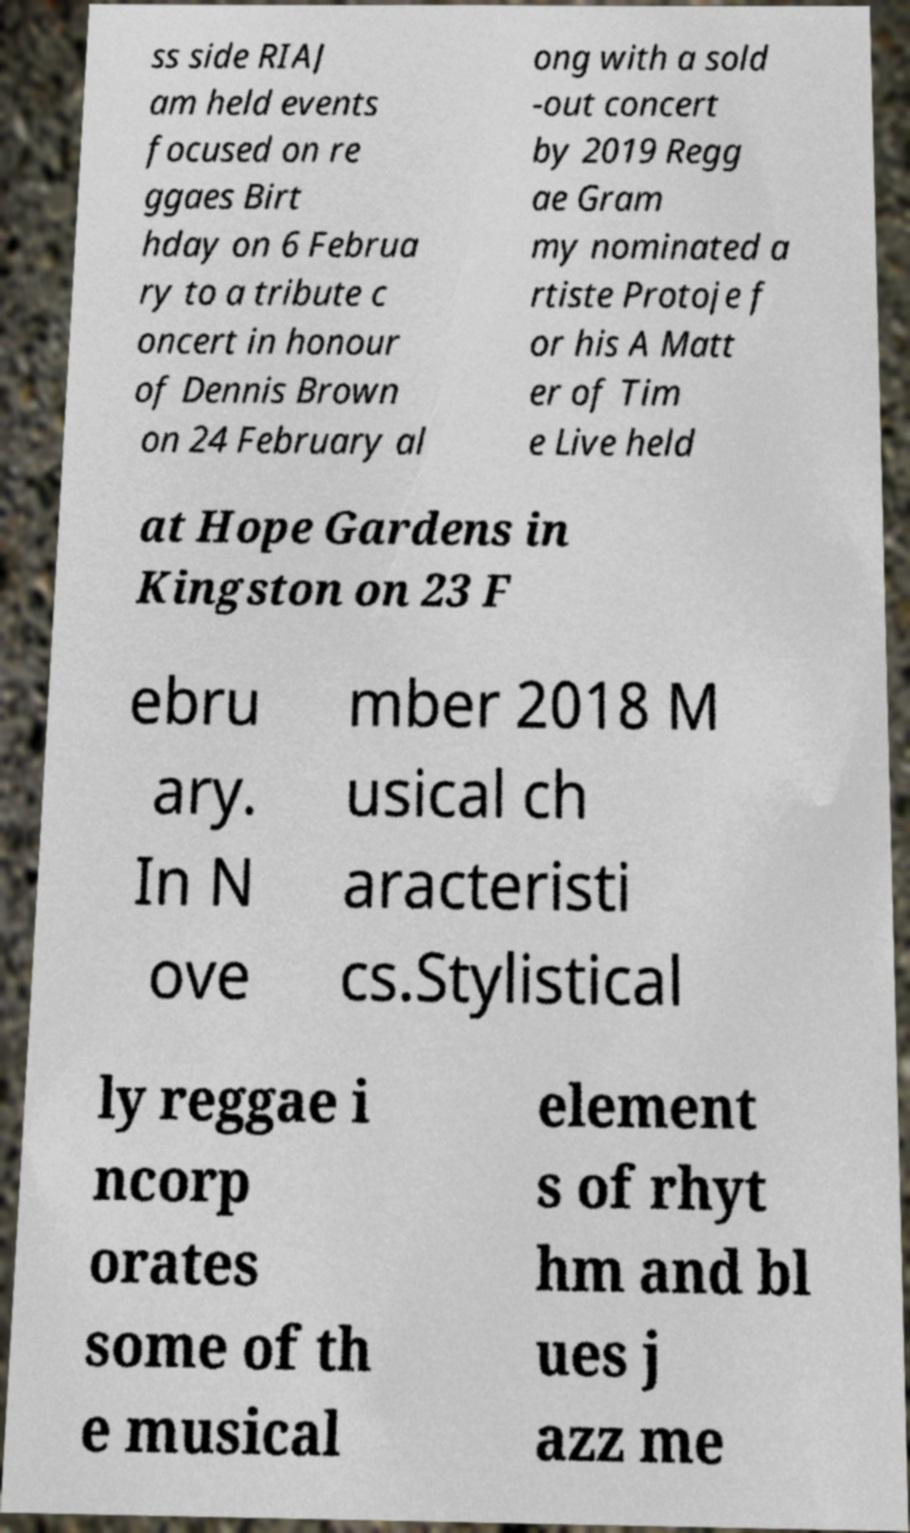Could you extract and type out the text from this image? ss side RIAJ am held events focused on re ggaes Birt hday on 6 Februa ry to a tribute c oncert in honour of Dennis Brown on 24 February al ong with a sold -out concert by 2019 Regg ae Gram my nominated a rtiste Protoje f or his A Matt er of Tim e Live held at Hope Gardens in Kingston on 23 F ebru ary. In N ove mber 2018 M usical ch aracteristi cs.Stylistical ly reggae i ncorp orates some of th e musical element s of rhyt hm and bl ues j azz me 